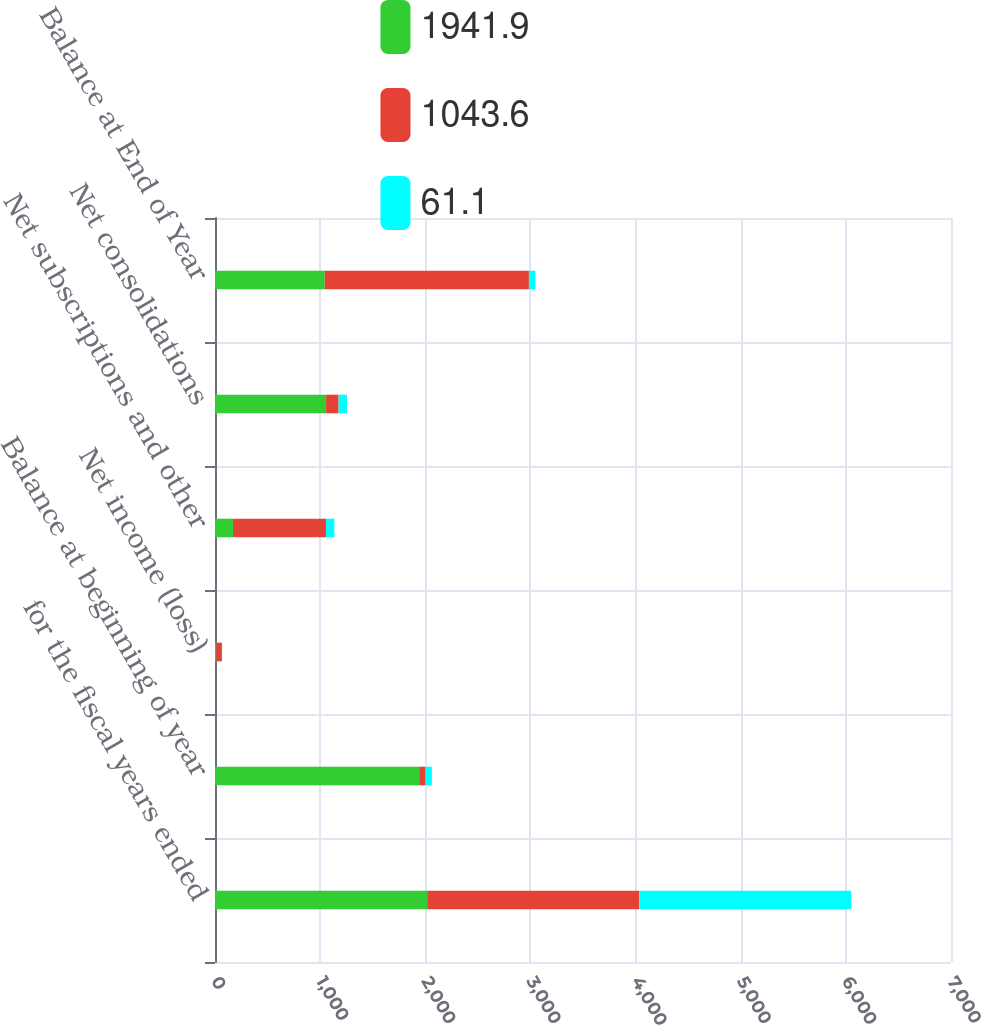<chart> <loc_0><loc_0><loc_500><loc_500><stacked_bar_chart><ecel><fcel>for the fiscal years ended<fcel>Balance at beginning of year<fcel>Net income (loss)<fcel>Net subscriptions and other<fcel>Net consolidations<fcel>Balance at End of Year<nl><fcel>1941.9<fcel>2018<fcel>1941.9<fcel>12.8<fcel>170.9<fcel>1056.4<fcel>1043.6<nl><fcel>1043.6<fcel>2017<fcel>61.1<fcel>53<fcel>884.3<fcel>118.8<fcel>1941.9<nl><fcel>61.1<fcel>2016<fcel>59.6<fcel>1.6<fcel>79.9<fcel>80<fcel>61.1<nl></chart> 